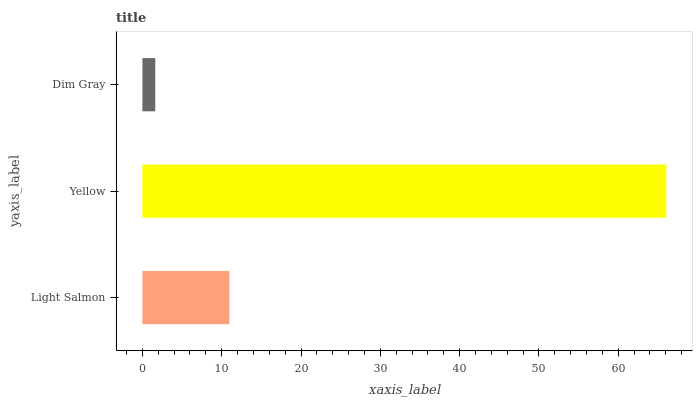Is Dim Gray the minimum?
Answer yes or no. Yes. Is Yellow the maximum?
Answer yes or no. Yes. Is Yellow the minimum?
Answer yes or no. No. Is Dim Gray the maximum?
Answer yes or no. No. Is Yellow greater than Dim Gray?
Answer yes or no. Yes. Is Dim Gray less than Yellow?
Answer yes or no. Yes. Is Dim Gray greater than Yellow?
Answer yes or no. No. Is Yellow less than Dim Gray?
Answer yes or no. No. Is Light Salmon the high median?
Answer yes or no. Yes. Is Light Salmon the low median?
Answer yes or no. Yes. Is Dim Gray the high median?
Answer yes or no. No. Is Dim Gray the low median?
Answer yes or no. No. 